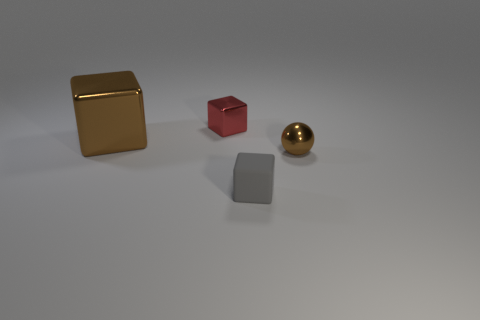Subtract all red metallic blocks. How many blocks are left? 2 Add 1 brown balls. How many objects exist? 5 Subtract all gray cubes. How many cubes are left? 2 Add 2 large red spheres. How many large red spheres exist? 2 Subtract 0 yellow blocks. How many objects are left? 4 Subtract all cubes. How many objects are left? 1 Subtract 1 cubes. How many cubes are left? 2 Subtract all blue cubes. Subtract all yellow cylinders. How many cubes are left? 3 Subtract all yellow balls. How many green cubes are left? 0 Subtract all brown blocks. Subtract all metallic objects. How many objects are left? 0 